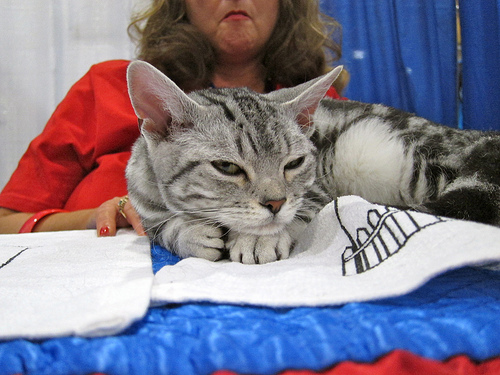<image>
Is the women behind the cat? Yes. From this viewpoint, the women is positioned behind the cat, with the cat partially or fully occluding the women. Where is the cat in relation to the ring? Is it in front of the ring? Yes. The cat is positioned in front of the ring, appearing closer to the camera viewpoint. Is there a cat in front of the curtain? Yes. The cat is positioned in front of the curtain, appearing closer to the camera viewpoint. 